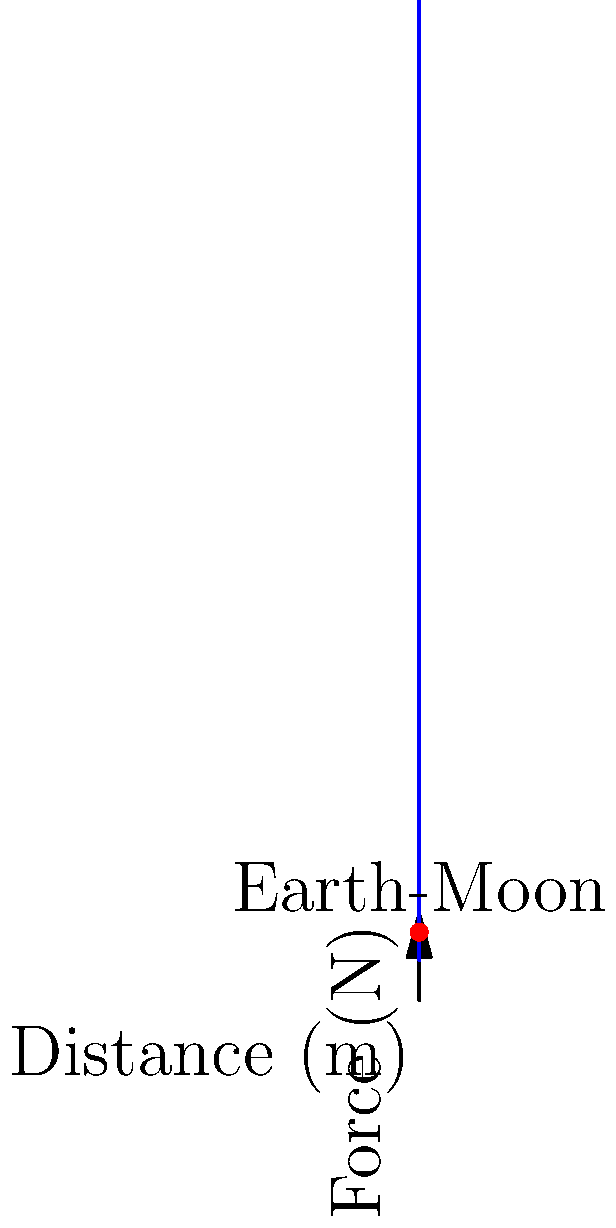As an innovative startup founder pushing the boundaries of science, you're developing a novel propulsion system for interplanetary travel. To optimize your design, you need to accurately calculate gravitational forces. Given that the mass of Earth is $5.97 \times 10^{24}$ kg, the mass of the Moon is $7.34 \times 10^{22}$ kg, and the average distance between their centers is $3.84 \times 10^8$ m, calculate the gravitational force between Earth and the Moon. Use the gravitational constant $G = 6.67430 \times 10^{-11}$ $\text{N}\cdot\text{m}^2/\text{kg}^2$. To calculate the gravitational force between two celestial bodies, we use Newton's law of universal gravitation:

$$F = G \frac{M_1 M_2}{r^2}$$

Where:
- $F$ is the gravitational force in Newtons (N)
- $G$ is the gravitational constant: $6.67430 \times 10^{-11}$ $\text{N}\cdot\text{m}^2/\text{kg}^2$
- $M_1$ is the mass of Earth: $5.97 \times 10^{24}$ kg
- $M_2$ is the mass of the Moon: $7.34 \times 10^{22}$ kg
- $r$ is the distance between the centers of the two bodies: $3.84 \times 10^8$ m

Let's substitute these values into the equation:

$$F = (6.67430 \times 10^{-11}) \frac{(5.97 \times 10^{24})(7.34 \times 10^{22})}{(3.84 \times 10^8)^2}$$

Simplifying:

$$F = (6.67430 \times 10^{-11}) \frac{4.38198 \times 10^{47}}{1.47456 \times 10^{17}}$$

$$F = (6.67430 \times 10^{-11})(2.97172 \times 10^{30})$$

$$F = 1.98245 \times 10^{20}$$

Therefore, the gravitational force between Earth and the Moon is approximately $1.98 \times 10^{20}$ N.
Answer: $1.98 \times 10^{20}$ N 